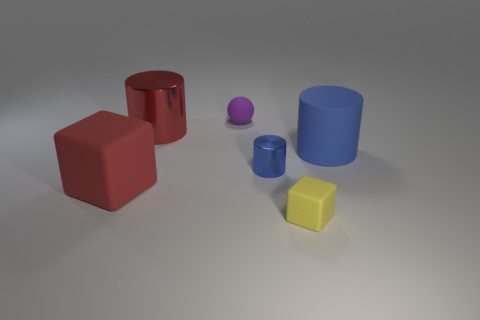There is a blue cylinder that is to the left of the tiny yellow rubber thing; how big is it?
Offer a terse response. Small. What size is the metal object in front of the big object on the right side of the tiny purple rubber thing?
Ensure brevity in your answer.  Small. Are there more big brown matte cylinders than large things?
Make the answer very short. No. Is the number of large cylinders behind the tiny metallic object greater than the number of small yellow rubber cubes behind the small yellow object?
Provide a short and direct response. Yes. There is a object that is right of the big red cube and left of the rubber ball; how big is it?
Provide a short and direct response. Large. What number of yellow cubes are the same size as the yellow thing?
Your answer should be compact. 0. What material is the big thing that is the same color as the big cube?
Make the answer very short. Metal. There is a metallic object on the left side of the tiny blue metallic object; is it the same shape as the blue matte object?
Provide a succinct answer. Yes. Are there fewer big metallic cylinders that are to the right of the tiny matte sphere than red objects?
Ensure brevity in your answer.  Yes. Are there any other large cubes that have the same color as the big rubber cube?
Your response must be concise. No. 